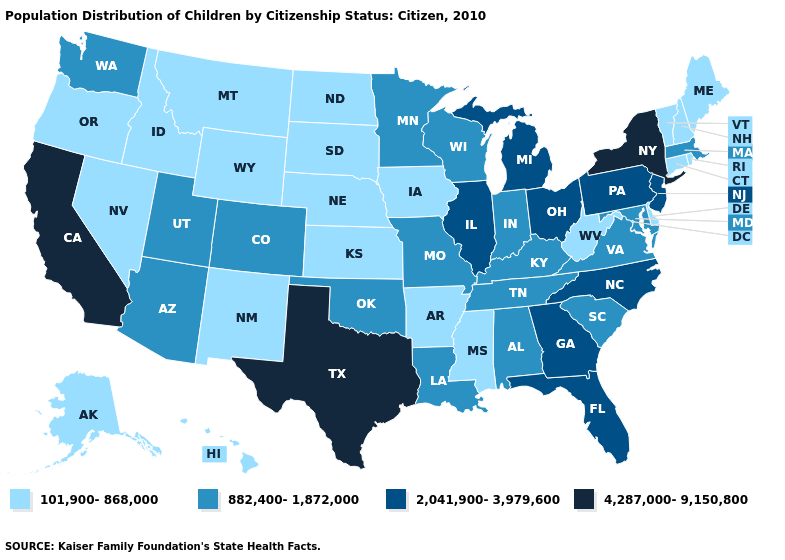What is the value of Georgia?
Keep it brief. 2,041,900-3,979,600. Among the states that border Virginia , does West Virginia have the lowest value?
Concise answer only. Yes. Name the states that have a value in the range 4,287,000-9,150,800?
Answer briefly. California, New York, Texas. Does Indiana have the highest value in the USA?
Keep it brief. No. Is the legend a continuous bar?
Keep it brief. No. Name the states that have a value in the range 101,900-868,000?
Answer briefly. Alaska, Arkansas, Connecticut, Delaware, Hawaii, Idaho, Iowa, Kansas, Maine, Mississippi, Montana, Nebraska, Nevada, New Hampshire, New Mexico, North Dakota, Oregon, Rhode Island, South Dakota, Vermont, West Virginia, Wyoming. Does New York have the highest value in the Northeast?
Be succinct. Yes. What is the lowest value in the Northeast?
Keep it brief. 101,900-868,000. What is the lowest value in the USA?
Quick response, please. 101,900-868,000. What is the value of Colorado?
Keep it brief. 882,400-1,872,000. Name the states that have a value in the range 101,900-868,000?
Quick response, please. Alaska, Arkansas, Connecticut, Delaware, Hawaii, Idaho, Iowa, Kansas, Maine, Mississippi, Montana, Nebraska, Nevada, New Hampshire, New Mexico, North Dakota, Oregon, Rhode Island, South Dakota, Vermont, West Virginia, Wyoming. Name the states that have a value in the range 101,900-868,000?
Concise answer only. Alaska, Arkansas, Connecticut, Delaware, Hawaii, Idaho, Iowa, Kansas, Maine, Mississippi, Montana, Nebraska, Nevada, New Hampshire, New Mexico, North Dakota, Oregon, Rhode Island, South Dakota, Vermont, West Virginia, Wyoming. Among the states that border Missouri , which have the highest value?
Quick response, please. Illinois. Which states have the lowest value in the USA?
Give a very brief answer. Alaska, Arkansas, Connecticut, Delaware, Hawaii, Idaho, Iowa, Kansas, Maine, Mississippi, Montana, Nebraska, Nevada, New Hampshire, New Mexico, North Dakota, Oregon, Rhode Island, South Dakota, Vermont, West Virginia, Wyoming. Which states have the highest value in the USA?
Quick response, please. California, New York, Texas. 